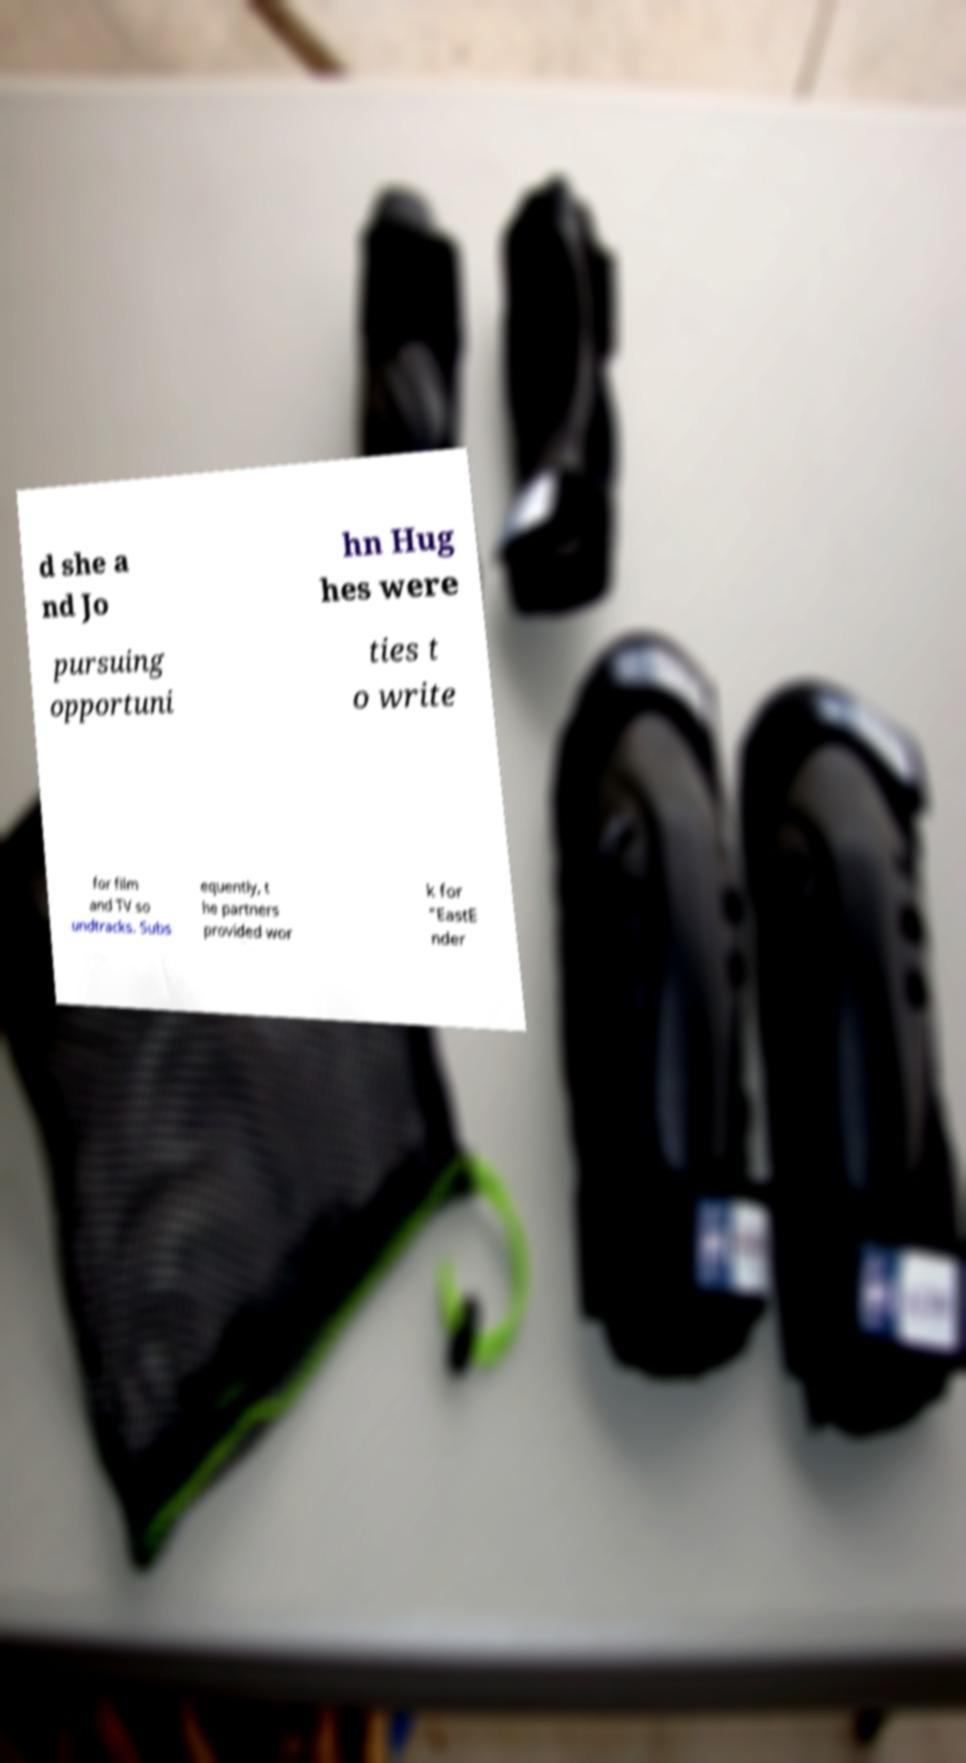What messages or text are displayed in this image? I need them in a readable, typed format. d she a nd Jo hn Hug hes were pursuing opportuni ties t o write for film and TV so undtracks. Subs equently, t he partners provided wor k for "EastE nder 